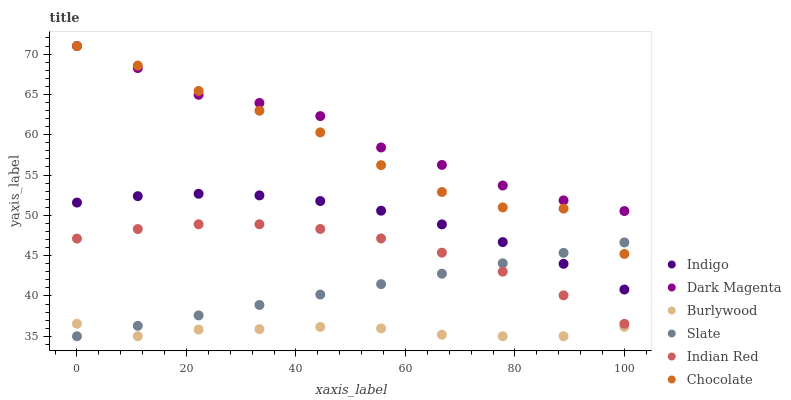Does Burlywood have the minimum area under the curve?
Answer yes or no. Yes. Does Dark Magenta have the maximum area under the curve?
Answer yes or no. Yes. Does Dark Magenta have the minimum area under the curve?
Answer yes or no. No. Does Burlywood have the maximum area under the curve?
Answer yes or no. No. Is Slate the smoothest?
Answer yes or no. Yes. Is Chocolate the roughest?
Answer yes or no. Yes. Is Dark Magenta the smoothest?
Answer yes or no. No. Is Dark Magenta the roughest?
Answer yes or no. No. Does Burlywood have the lowest value?
Answer yes or no. Yes. Does Dark Magenta have the lowest value?
Answer yes or no. No. Does Chocolate have the highest value?
Answer yes or no. Yes. Does Burlywood have the highest value?
Answer yes or no. No. Is Burlywood less than Dark Magenta?
Answer yes or no. Yes. Is Dark Magenta greater than Indian Red?
Answer yes or no. Yes. Does Burlywood intersect Slate?
Answer yes or no. Yes. Is Burlywood less than Slate?
Answer yes or no. No. Is Burlywood greater than Slate?
Answer yes or no. No. Does Burlywood intersect Dark Magenta?
Answer yes or no. No. 